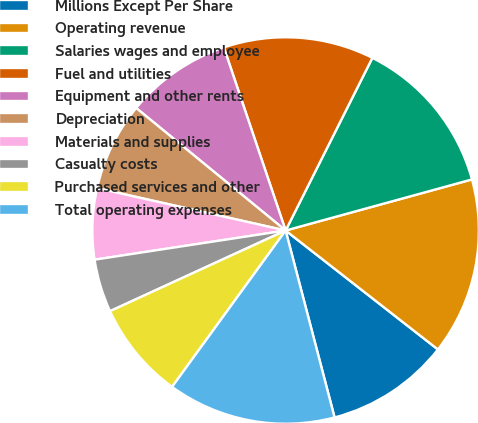<chart> <loc_0><loc_0><loc_500><loc_500><pie_chart><fcel>Millions Except Per Share<fcel>Operating revenue<fcel>Salaries wages and employee<fcel>Fuel and utilities<fcel>Equipment and other rents<fcel>Depreciation<fcel>Materials and supplies<fcel>Casualty costs<fcel>Purchased services and other<fcel>Total operating expenses<nl><fcel>10.37%<fcel>14.81%<fcel>13.33%<fcel>12.59%<fcel>8.89%<fcel>7.41%<fcel>5.93%<fcel>4.44%<fcel>8.15%<fcel>14.07%<nl></chart> 